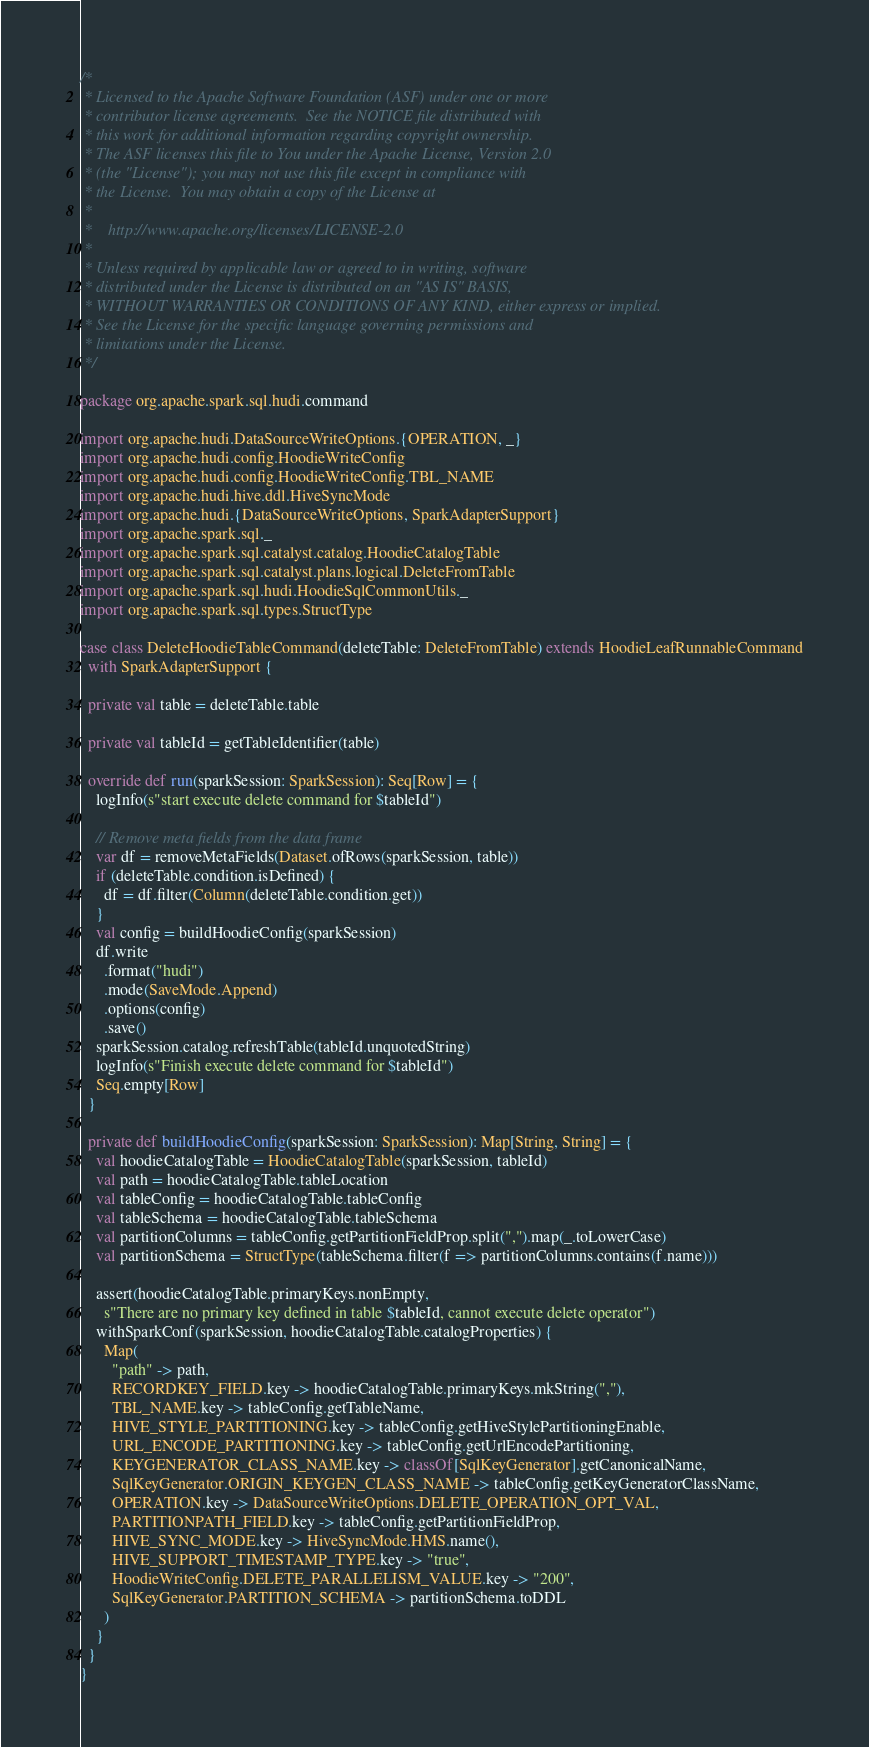<code> <loc_0><loc_0><loc_500><loc_500><_Scala_>/*
 * Licensed to the Apache Software Foundation (ASF) under one or more
 * contributor license agreements.  See the NOTICE file distributed with
 * this work for additional information regarding copyright ownership.
 * The ASF licenses this file to You under the Apache License, Version 2.0
 * (the "License"); you may not use this file except in compliance with
 * the License.  You may obtain a copy of the License at
 *
 *    http://www.apache.org/licenses/LICENSE-2.0
 *
 * Unless required by applicable law or agreed to in writing, software
 * distributed under the License is distributed on an "AS IS" BASIS,
 * WITHOUT WARRANTIES OR CONDITIONS OF ANY KIND, either express or implied.
 * See the License for the specific language governing permissions and
 * limitations under the License.
 */

package org.apache.spark.sql.hudi.command

import org.apache.hudi.DataSourceWriteOptions.{OPERATION, _}
import org.apache.hudi.config.HoodieWriteConfig
import org.apache.hudi.config.HoodieWriteConfig.TBL_NAME
import org.apache.hudi.hive.ddl.HiveSyncMode
import org.apache.hudi.{DataSourceWriteOptions, SparkAdapterSupport}
import org.apache.spark.sql._
import org.apache.spark.sql.catalyst.catalog.HoodieCatalogTable
import org.apache.spark.sql.catalyst.plans.logical.DeleteFromTable
import org.apache.spark.sql.hudi.HoodieSqlCommonUtils._
import org.apache.spark.sql.types.StructType

case class DeleteHoodieTableCommand(deleteTable: DeleteFromTable) extends HoodieLeafRunnableCommand
  with SparkAdapterSupport {

  private val table = deleteTable.table

  private val tableId = getTableIdentifier(table)

  override def run(sparkSession: SparkSession): Seq[Row] = {
    logInfo(s"start execute delete command for $tableId")

    // Remove meta fields from the data frame
    var df = removeMetaFields(Dataset.ofRows(sparkSession, table))
    if (deleteTable.condition.isDefined) {
      df = df.filter(Column(deleteTable.condition.get))
    }
    val config = buildHoodieConfig(sparkSession)
    df.write
      .format("hudi")
      .mode(SaveMode.Append)
      .options(config)
      .save()
    sparkSession.catalog.refreshTable(tableId.unquotedString)
    logInfo(s"Finish execute delete command for $tableId")
    Seq.empty[Row]
  }

  private def buildHoodieConfig(sparkSession: SparkSession): Map[String, String] = {
    val hoodieCatalogTable = HoodieCatalogTable(sparkSession, tableId)
    val path = hoodieCatalogTable.tableLocation
    val tableConfig = hoodieCatalogTable.tableConfig
    val tableSchema = hoodieCatalogTable.tableSchema
    val partitionColumns = tableConfig.getPartitionFieldProp.split(",").map(_.toLowerCase)
    val partitionSchema = StructType(tableSchema.filter(f => partitionColumns.contains(f.name)))

    assert(hoodieCatalogTable.primaryKeys.nonEmpty,
      s"There are no primary key defined in table $tableId, cannot execute delete operator")
    withSparkConf(sparkSession, hoodieCatalogTable.catalogProperties) {
      Map(
        "path" -> path,
        RECORDKEY_FIELD.key -> hoodieCatalogTable.primaryKeys.mkString(","),
        TBL_NAME.key -> tableConfig.getTableName,
        HIVE_STYLE_PARTITIONING.key -> tableConfig.getHiveStylePartitioningEnable,
        URL_ENCODE_PARTITIONING.key -> tableConfig.getUrlEncodePartitioning,
        KEYGENERATOR_CLASS_NAME.key -> classOf[SqlKeyGenerator].getCanonicalName,
        SqlKeyGenerator.ORIGIN_KEYGEN_CLASS_NAME -> tableConfig.getKeyGeneratorClassName,
        OPERATION.key -> DataSourceWriteOptions.DELETE_OPERATION_OPT_VAL,
        PARTITIONPATH_FIELD.key -> tableConfig.getPartitionFieldProp,
        HIVE_SYNC_MODE.key -> HiveSyncMode.HMS.name(),
        HIVE_SUPPORT_TIMESTAMP_TYPE.key -> "true",
        HoodieWriteConfig.DELETE_PARALLELISM_VALUE.key -> "200",
        SqlKeyGenerator.PARTITION_SCHEMA -> partitionSchema.toDDL
      )
    }
  }
}
</code> 